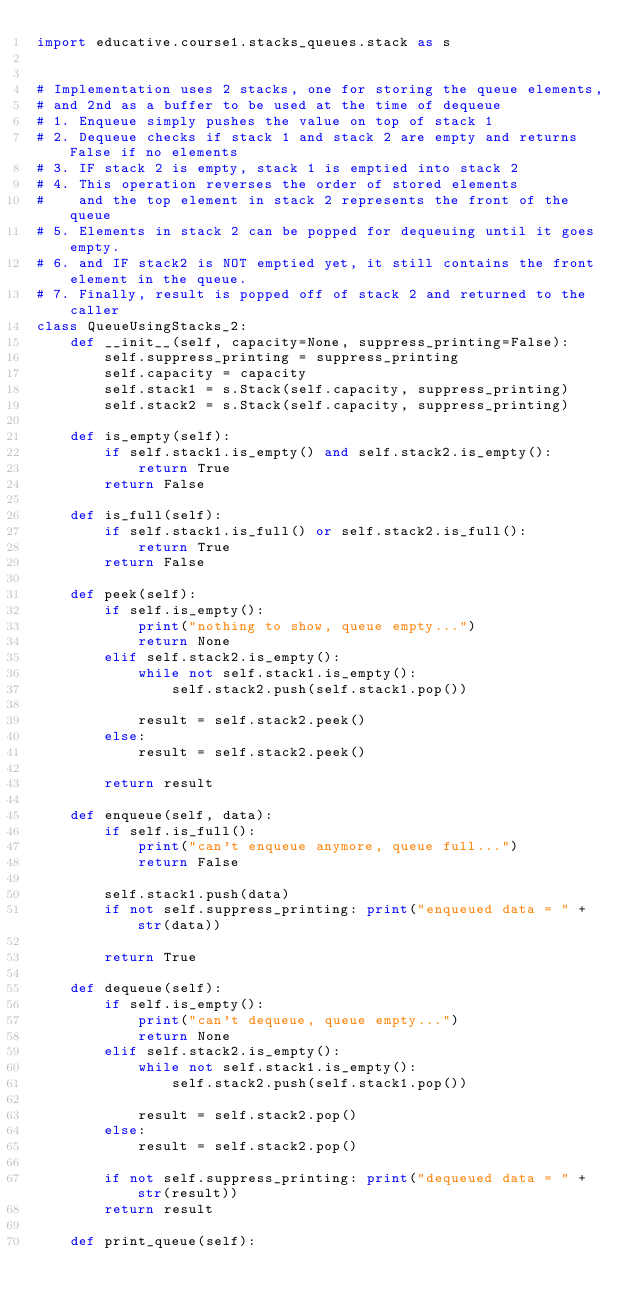Convert code to text. <code><loc_0><loc_0><loc_500><loc_500><_Python_>import educative.course1.stacks_queues.stack as s


# Implementation uses 2 stacks, one for storing the queue elements,
# and 2nd as a buffer to be used at the time of dequeue
# 1. Enqueue simply pushes the value on top of stack 1
# 2. Dequeue checks if stack 1 and stack 2 are empty and returns False if no elements
# 3. IF stack 2 is empty, stack 1 is emptied into stack 2
# 4. This operation reverses the order of stored elements
#    and the top element in stack 2 represents the front of the queue
# 5. Elements in stack 2 can be popped for dequeuing until it goes empty.
# 6. and IF stack2 is NOT emptied yet, it still contains the front element in the queue.
# 7. Finally, result is popped off of stack 2 and returned to the caller
class QueueUsingStacks_2:
    def __init__(self, capacity=None, suppress_printing=False):
        self.suppress_printing = suppress_printing
        self.capacity = capacity
        self.stack1 = s.Stack(self.capacity, suppress_printing)
        self.stack2 = s.Stack(self.capacity, suppress_printing)

    def is_empty(self):
        if self.stack1.is_empty() and self.stack2.is_empty():
            return True
        return False

    def is_full(self):
        if self.stack1.is_full() or self.stack2.is_full():
            return True
        return False

    def peek(self):
        if self.is_empty():
            print("nothing to show, queue empty...")
            return None
        elif self.stack2.is_empty():
            while not self.stack1.is_empty():
                self.stack2.push(self.stack1.pop())

            result = self.stack2.peek()
        else:
            result = self.stack2.peek()

        return result

    def enqueue(self, data):
        if self.is_full():
            print("can't enqueue anymore, queue full...")
            return False

        self.stack1.push(data)
        if not self.suppress_printing: print("enqueued data = " + str(data))

        return True

    def dequeue(self):
        if self.is_empty():
            print("can't dequeue, queue empty...")
            return None
        elif self.stack2.is_empty():
            while not self.stack1.is_empty():
                self.stack2.push(self.stack1.pop())

            result = self.stack2.pop()
        else:
            result = self.stack2.pop()

        if not self.suppress_printing: print("dequeued data = " + str(result))
        return result

    def print_queue(self):</code> 